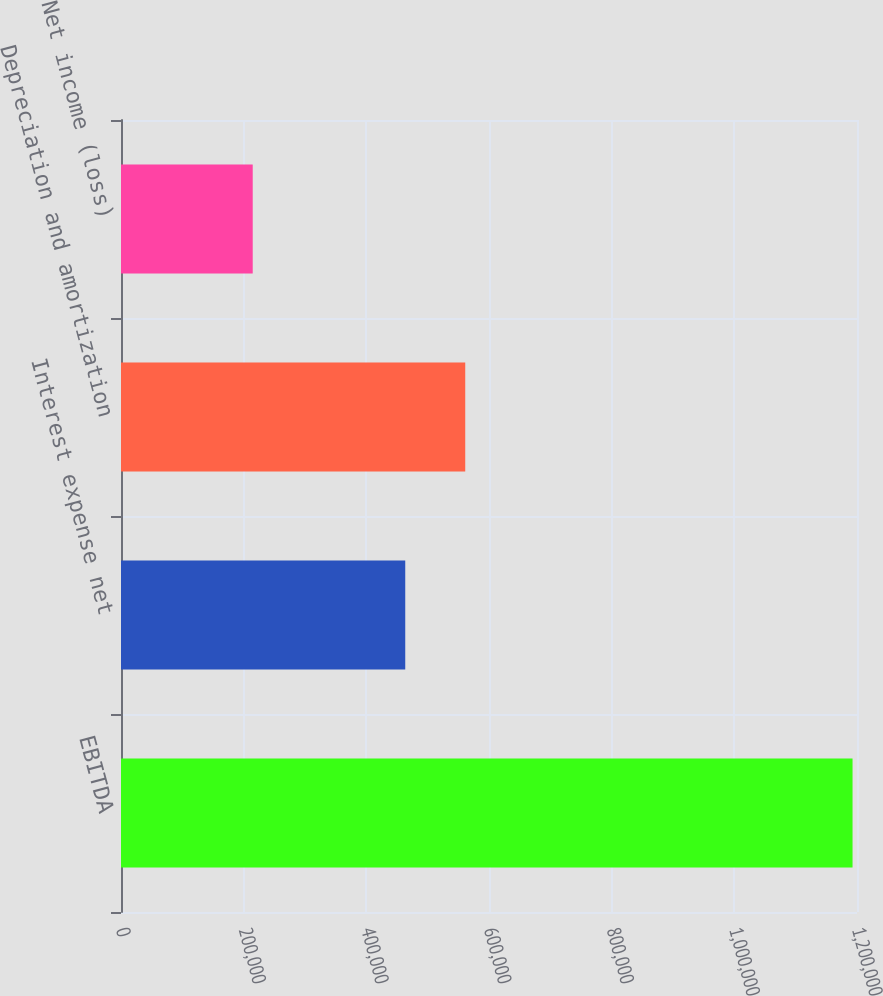Convert chart to OTSL. <chart><loc_0><loc_0><loc_500><loc_500><bar_chart><fcel>EBITDA<fcel>Interest expense net<fcel>Depreciation and amortization<fcel>Net income (loss)<nl><fcel>1.19272e+06<fcel>463445<fcel>561240<fcel>214769<nl></chart> 